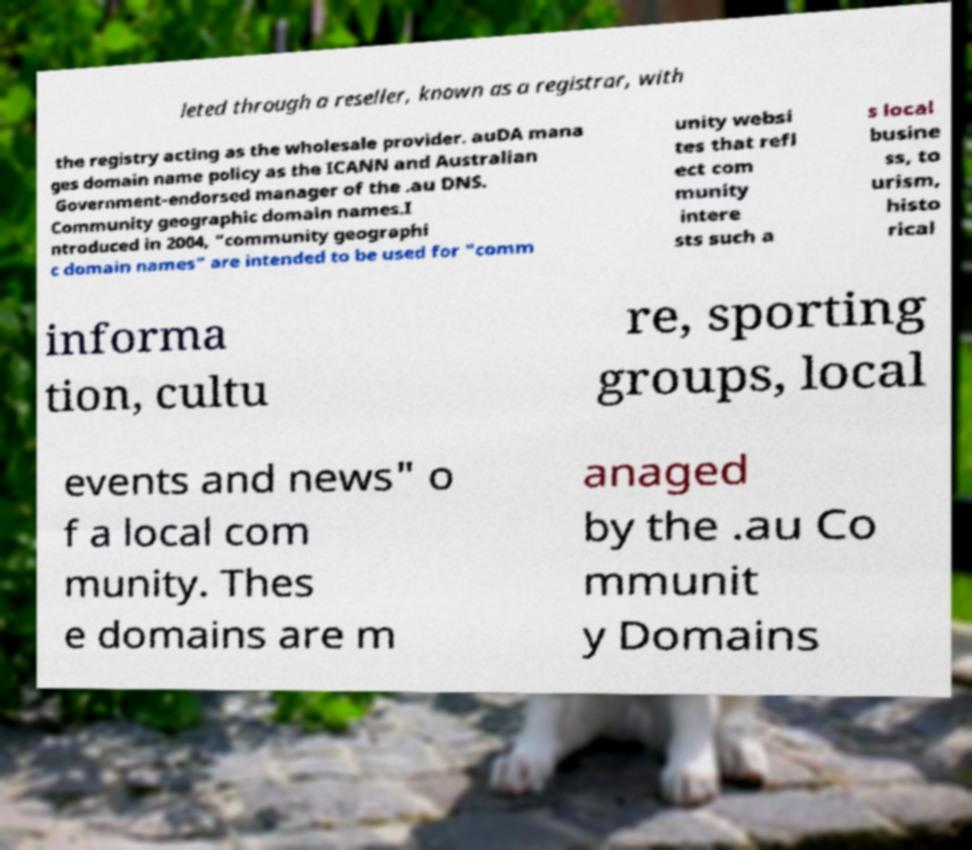Can you accurately transcribe the text from the provided image for me? leted through a reseller, known as a registrar, with the registry acting as the wholesale provider. auDA mana ges domain name policy as the ICANN and Australian Government-endorsed manager of the .au DNS. Community geographic domain names.I ntroduced in 2004, "community geographi c domain names" are intended to be used for "comm unity websi tes that refl ect com munity intere sts such a s local busine ss, to urism, histo rical informa tion, cultu re, sporting groups, local events and news" o f a local com munity. Thes e domains are m anaged by the .au Co mmunit y Domains 